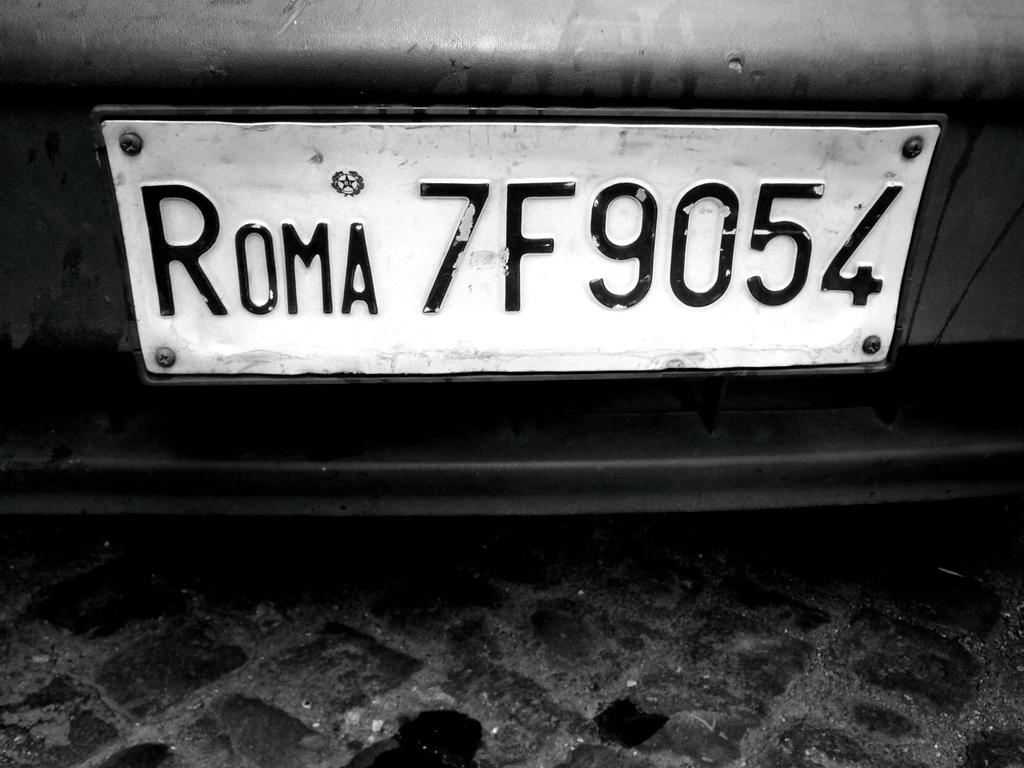<image>
Render a clear and concise summary of the photo. A license plate from a foreign country that reads "Roma 7F9054" 